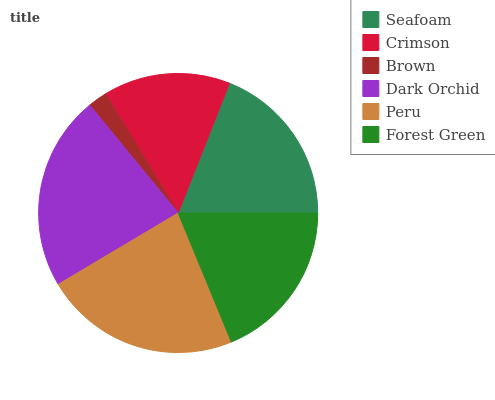Is Brown the minimum?
Answer yes or no. Yes. Is Peru the maximum?
Answer yes or no. Yes. Is Crimson the minimum?
Answer yes or no. No. Is Crimson the maximum?
Answer yes or no. No. Is Seafoam greater than Crimson?
Answer yes or no. Yes. Is Crimson less than Seafoam?
Answer yes or no. Yes. Is Crimson greater than Seafoam?
Answer yes or no. No. Is Seafoam less than Crimson?
Answer yes or no. No. Is Seafoam the high median?
Answer yes or no. Yes. Is Forest Green the low median?
Answer yes or no. Yes. Is Peru the high median?
Answer yes or no. No. Is Seafoam the low median?
Answer yes or no. No. 